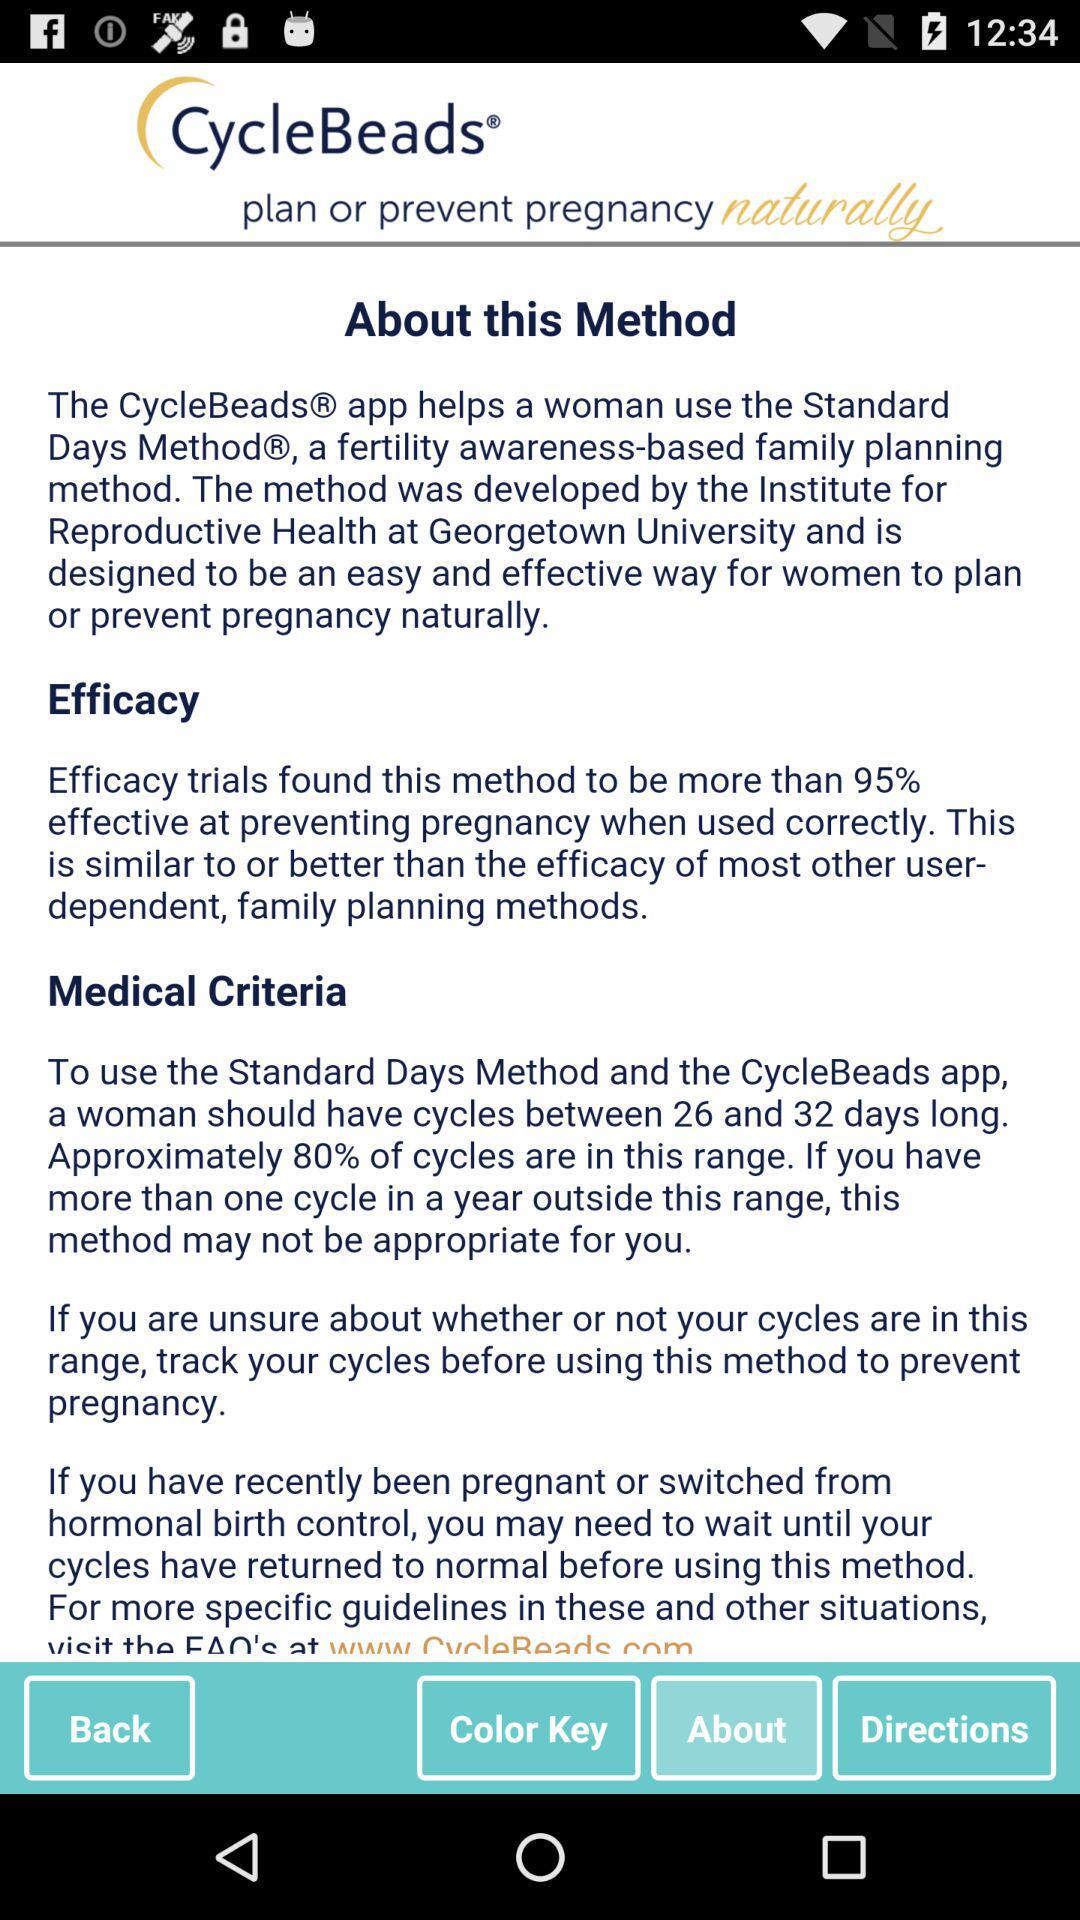How many percent of cycles are between 26 and 32 days long?
Answer the question using a single word or phrase. 80% 